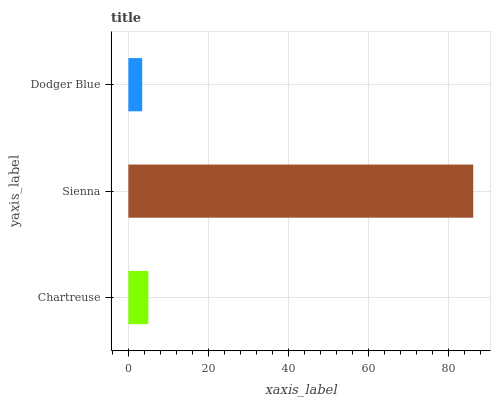Is Dodger Blue the minimum?
Answer yes or no. Yes. Is Sienna the maximum?
Answer yes or no. Yes. Is Sienna the minimum?
Answer yes or no. No. Is Dodger Blue the maximum?
Answer yes or no. No. Is Sienna greater than Dodger Blue?
Answer yes or no. Yes. Is Dodger Blue less than Sienna?
Answer yes or no. Yes. Is Dodger Blue greater than Sienna?
Answer yes or no. No. Is Sienna less than Dodger Blue?
Answer yes or no. No. Is Chartreuse the high median?
Answer yes or no. Yes. Is Chartreuse the low median?
Answer yes or no. Yes. Is Dodger Blue the high median?
Answer yes or no. No. Is Sienna the low median?
Answer yes or no. No. 